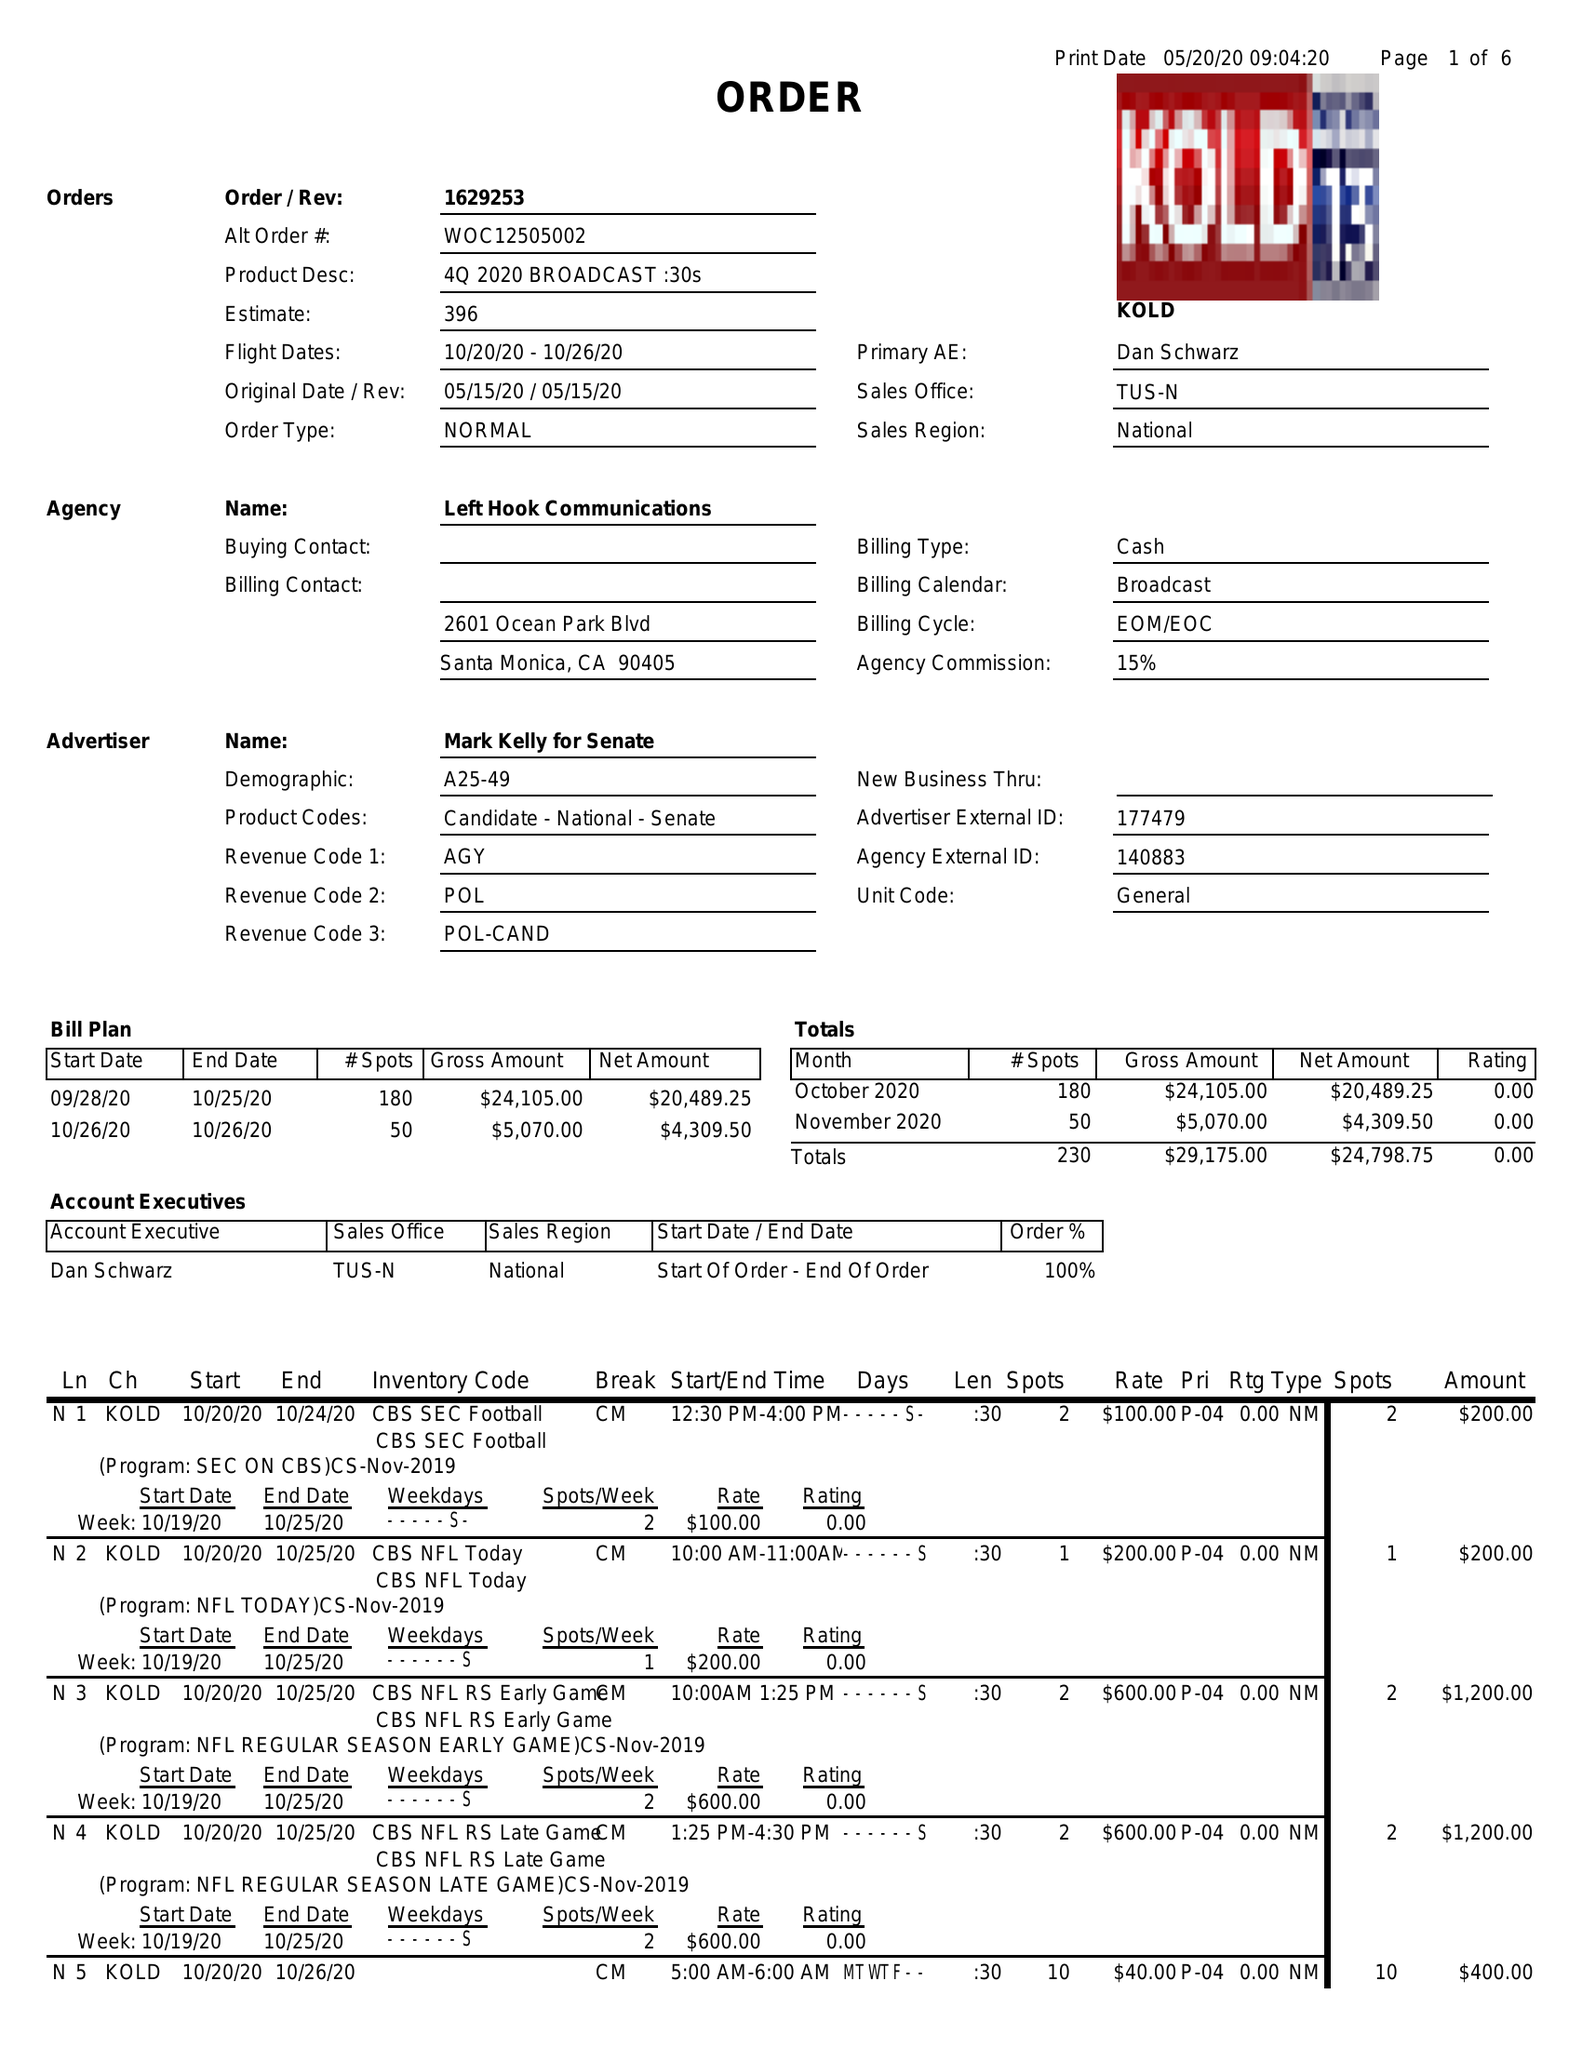What is the value for the flight_to?
Answer the question using a single word or phrase. 10/26/20 